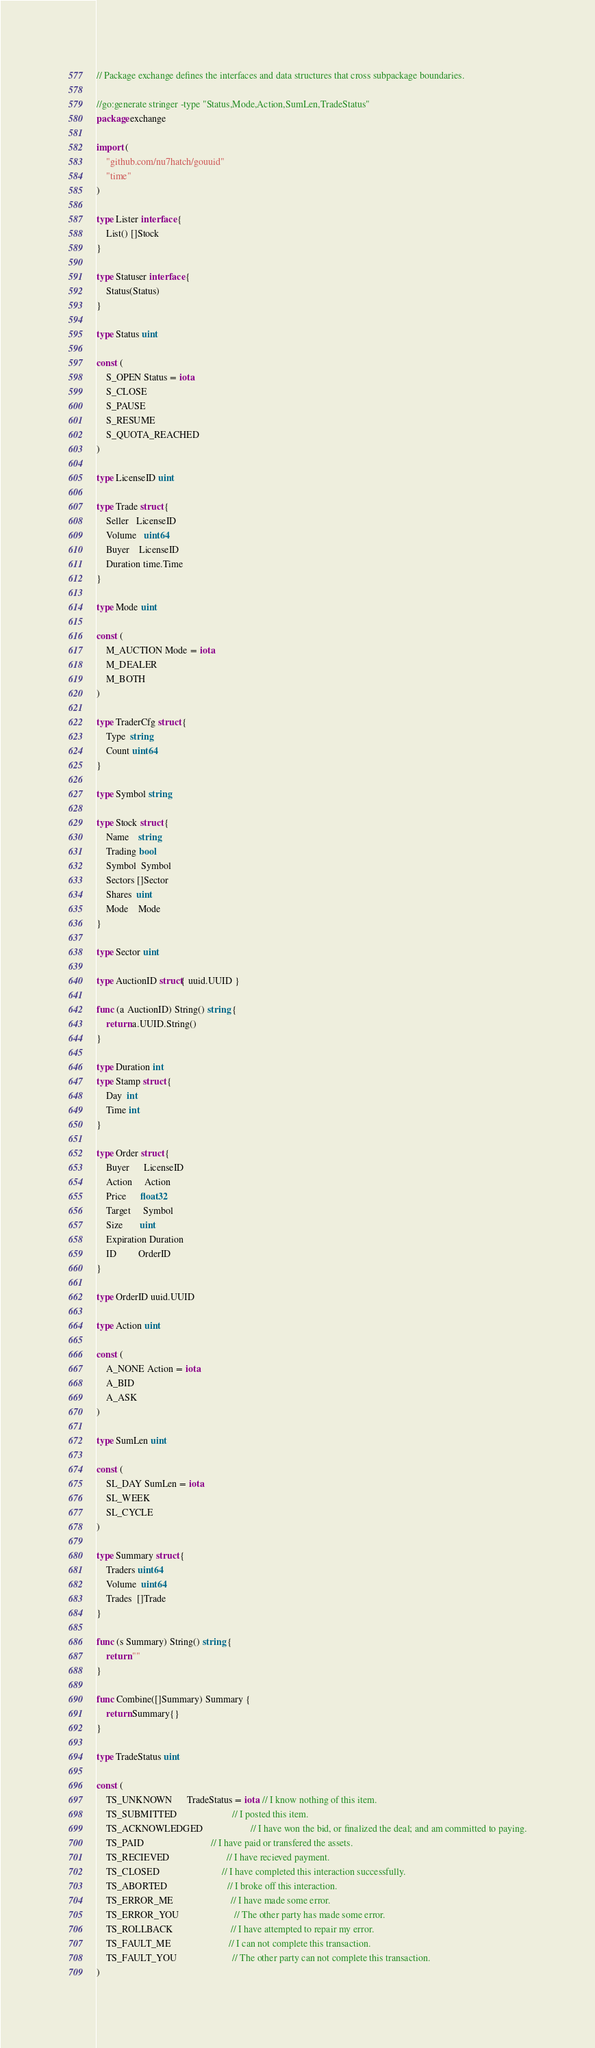<code> <loc_0><loc_0><loc_500><loc_500><_Go_>// Package exchange defines the interfaces and data structures that cross subpackage boundaries.

//go:generate stringer -type "Status,Mode,Action,SumLen,TradeStatus"
package exchange

import (
	"github.com/nu7hatch/gouuid"
	"time"
)

type Lister interface {
	List() []Stock
}

type Statuser interface {
	Status(Status)
}

type Status uint

const (
	S_OPEN Status = iota
	S_CLOSE
	S_PAUSE
	S_RESUME
	S_QUOTA_REACHED
)

type LicenseID uint

type Trade struct {
	Seller   LicenseID
	Volume   uint64
	Buyer    LicenseID
	Duration time.Time
}

type Mode uint

const (
	M_AUCTION Mode = iota
	M_DEALER
	M_BOTH
)

type TraderCfg struct {
	Type  string
	Count uint64
}

type Symbol string

type Stock struct {
	Name    string
	Trading bool
	Symbol  Symbol
	Sectors []Sector
	Shares  uint
	Mode    Mode
}

type Sector uint

type AuctionID struct{ uuid.UUID }

func (a AuctionID) String() string {
	return a.UUID.String()
}

type Duration int
type Stamp struct {
	Day  int
	Time int
}

type Order struct {
	Buyer      LicenseID
	Action     Action
	Price      float32
	Target     Symbol
	Size       uint
	Expiration Duration
	ID         OrderID
}

type OrderID uuid.UUID

type Action uint

const (
	A_NONE Action = iota
	A_BID
	A_ASK
)

type SumLen uint

const (
	SL_DAY SumLen = iota
	SL_WEEK
	SL_CYCLE
)

type Summary struct {
	Traders uint64
	Volume  uint64
	Trades  []Trade
}

func (s Summary) String() string {
	return ""
}

func Combine([]Summary) Summary {
	return Summary{}
}

type TradeStatus uint

const (
	TS_UNKNOWN      TradeStatus = iota // I know nothing of this item.
	TS_SUBMITTED                       // I posted this item.
	TS_ACKNOWLEDGED                    // I have won the bid, or finalized the deal; and am committed to paying.
	TS_PAID                            // I have paid or transfered the assets.
	TS_RECIEVED                        // I have recieved payment.
	TS_CLOSED                          // I have completed this interaction successfully.
	TS_ABORTED                         // I broke off this interaction.
	TS_ERROR_ME                        // I have made some error.
	TS_ERROR_YOU                       // The other party has made some error.
	TS_ROLLBACK                        // I have attempted to repair my error.
	TS_FAULT_ME                        // I can not complete this transaction.
	TS_FAULT_YOU                       // The other party can not complete this transaction.
)
</code> 